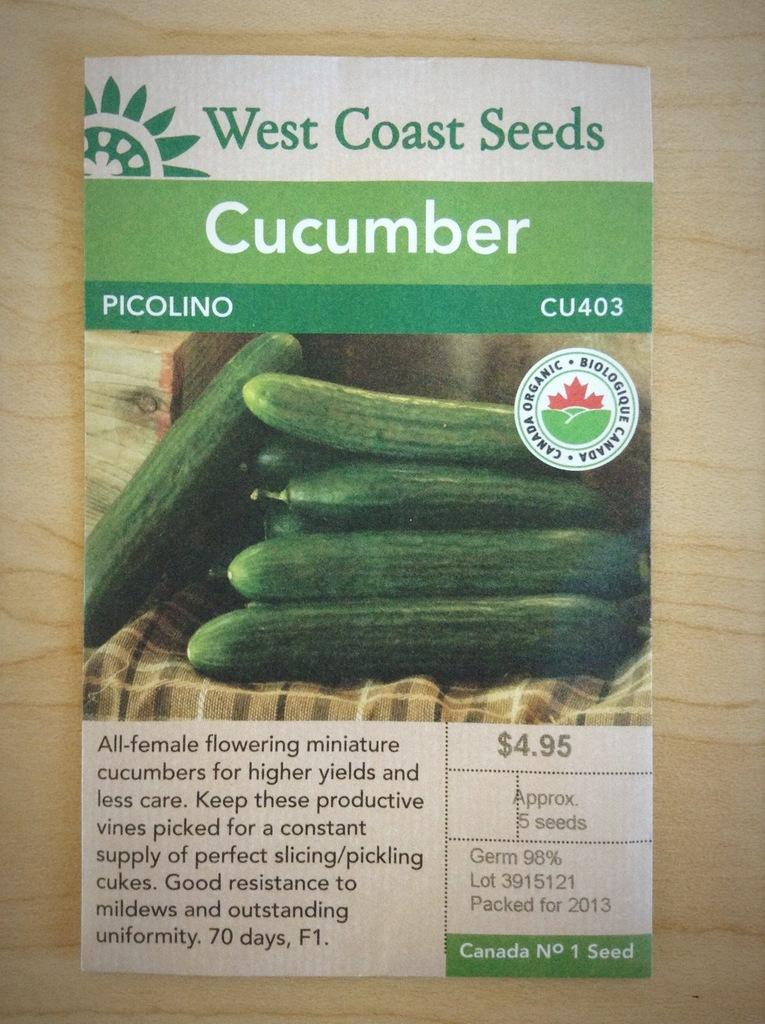What is present on the table in the image? There is a paper placed on a table in the image. What can be found on the paper? There is text and pictures of cucumber on the paper. What type of tin can be seen in the image? There is no tin present in the image. How does the team interact with the cucumber pictures on the paper? There is no team present in the image, and therefore no interaction can be observed. 